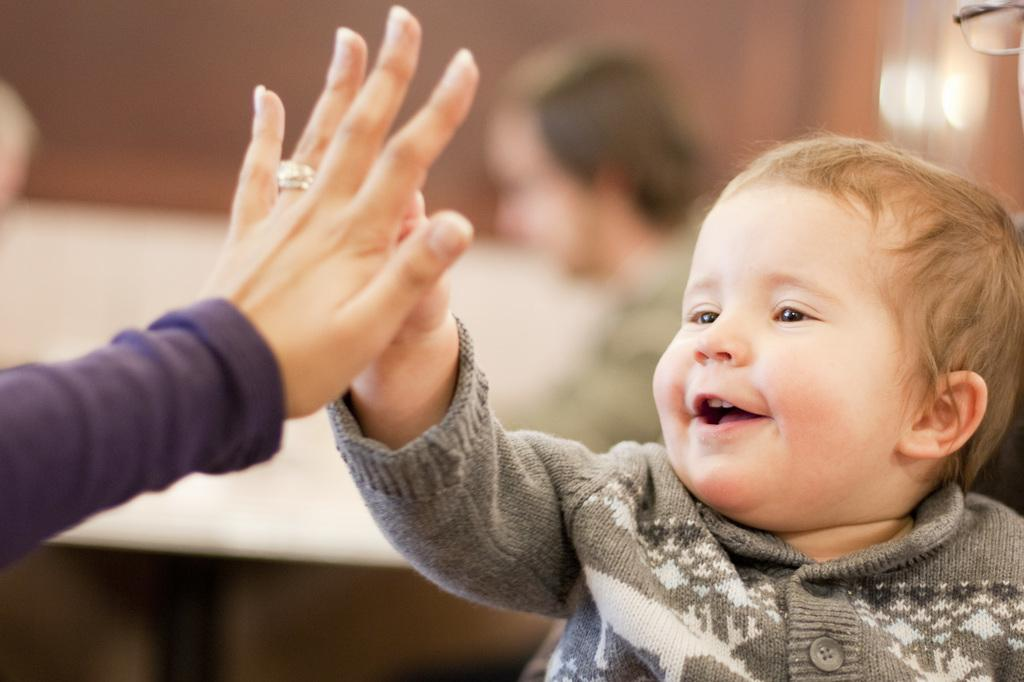What is the main subject of the image? There is a baby in the image. Can you describe what the baby is wearing? The baby is wearing a gray and white dress. Whose hand is visible in the image? There is another person's hand visible in the image. How would you describe the background of the image? The background of the image is blurred. What nation is the baby from in the image? There is no information about the baby's nationality in the image. Can you describe the wave pattern in the background of the image? There is no wave pattern visible in the image; the background is blurred. 